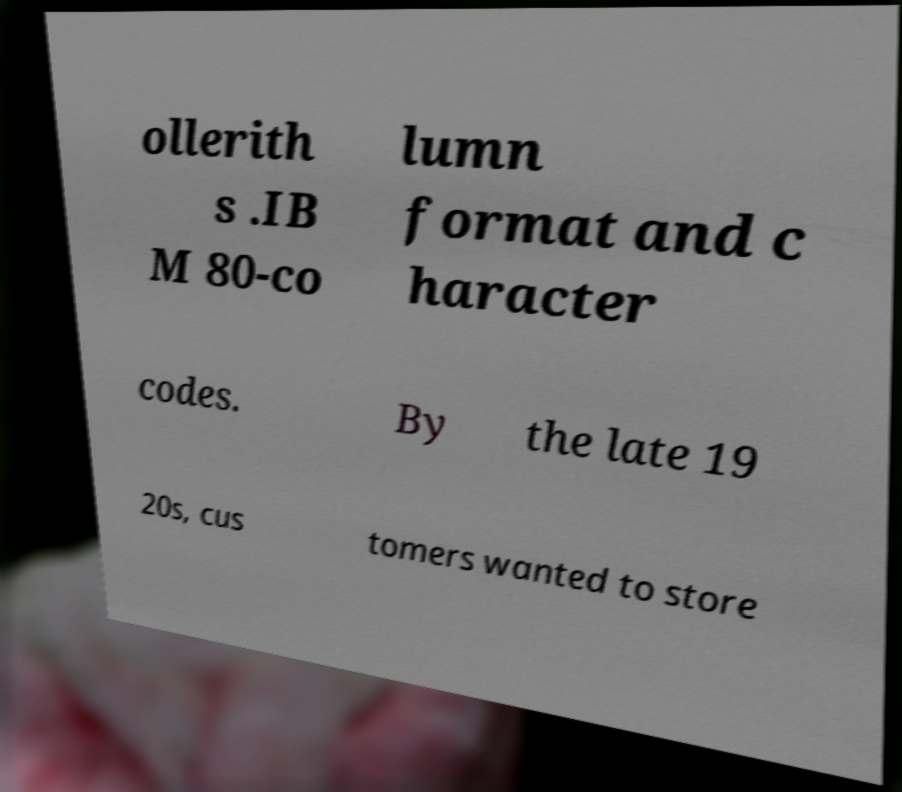Could you extract and type out the text from this image? ollerith s .IB M 80-co lumn format and c haracter codes. By the late 19 20s, cus tomers wanted to store 